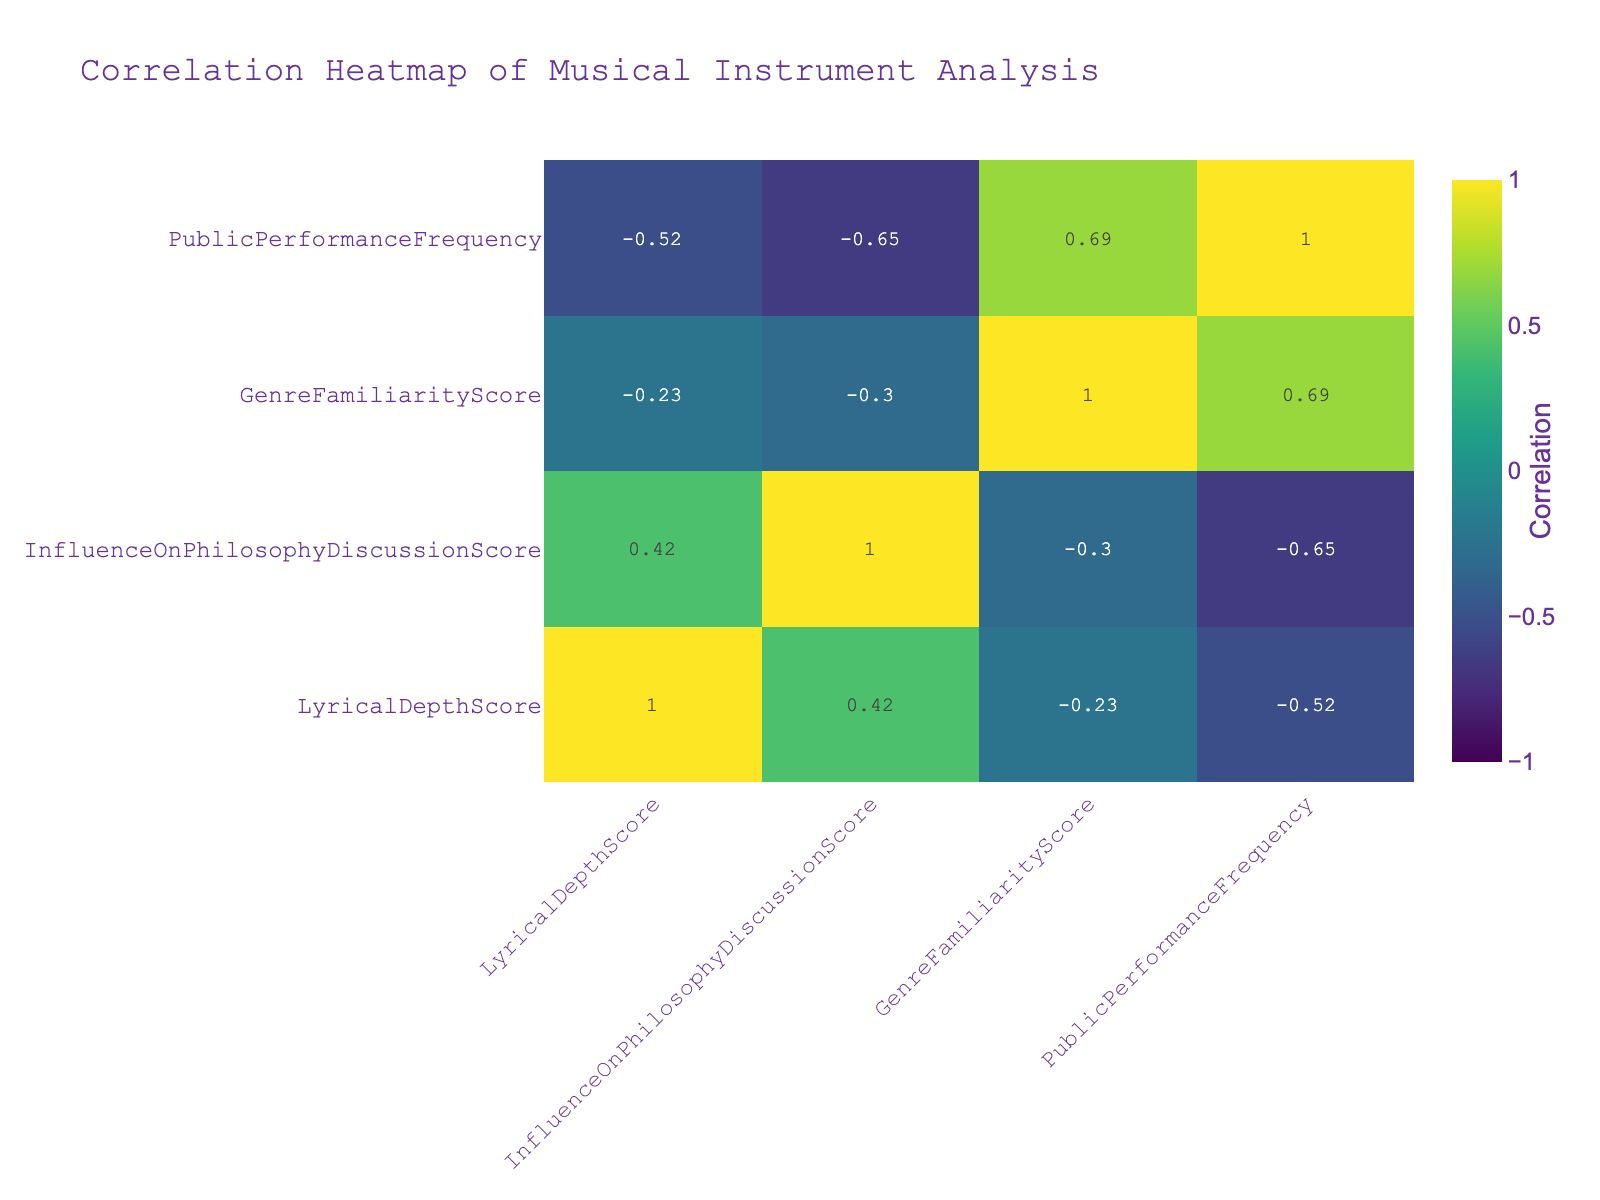What is the Lyrical Depth Score for the Piano? The Lyrical Depth Score for the Piano can be found directly in the table. Looking under the InstrumentType column for "Piano," the corresponding Lyrical Depth Score is 9.0.
Answer: 9.0 What is the maximum Influence On Philosophy Discussion Score, and which instrument scores it? To find the maximum Influence On Philosophy Discussion Score, we look at the scores in that column. Scanning through the values, the maximum score is 9.2, which is achieved by the Violin.
Answer: 9.2, Violin What is the average Lyrical Depth Score for instruments with a Public Performance Frequency of 4? The instruments with a Public Performance Frequency of 4 are Acoustic Guitar, Harmonica, and Ukulele. Their Lyrical Depth Scores are 8.5, 7.0, and 8.0 respectively. Adding these gives 8.5 + 7.0 + 8.0 = 23.5, and dividing by 3 gives an average of 23.5 / 3 = 7.83.
Answer: 7.83 Is the Acoustic Guitar more influential in philosophy discussions than the Electric Guitar? To answer this, we compare their Influence On Philosophy Discussion Scores. The Acoustic Guitar has a score of 9.0, while the Electric Guitar has a score of 7.8. Since 9.0 is greater than 7.8, we can conclude that the Acoustic Guitar is indeed more influential.
Answer: Yes Which instrument has the highest public performance frequency and what is its Lyrical Depth Score? By looking at the Public Performance Frequency column, we see that the Electric Guitar has the highest frequency score of 6. Checking its corresponding Lyrical Depth Score in the same row, we find it to be 6.8.
Answer: Electric Guitar, 6.8 If we find the difference between the average Lyrical Depth Score of all instruments and the Lyrical Depth Score of Drums, what is the result? First, we calculate the average Lyrical Depth Score. The total Lyrical Depth Scores are 8.5 + 9.0 + 8.0 + 6.5 + 8.2 + 7.0 + 7.5 + 7.8 + 8.0 + 6.8 = 78.5, and there are 10 instruments, so the average is 78.5 / 10 = 7.85. The Lyrical Depth Score for Drums is 6.5. The difference is 7.85 - 6.5 = 1.35.
Answer: 1.35 Is there an instrument with a Lyrical Depth Score that is at least 8.0 and a Public Performance Frequency of 2? Checking the instruments that have a score of at least 8.0, we have Acoustic Guitar, Piano, Violin, Saxophone, and Ukulele. Looking at their Public Performance Frequencies, all except Violin and Flute have frequencies above 2. Therefore, there is no instrument meeting both criteria simultaneously.
Answer: No What is the relationship between Genre Familiarity Score and Influence On Philosophy Discussion Score? To understand this relationship, we can look for patterns in the corresponding scores. Observing both columns, we find that as the Genre Familiarity Scores increase, the Influence On Philosophy Discussion Scores generally fluctuate. The specific correlation can be calculated directly from the correlation table. In this case, it shows a positive correlation, indicating they may be related.
Answer: Positive correlation 